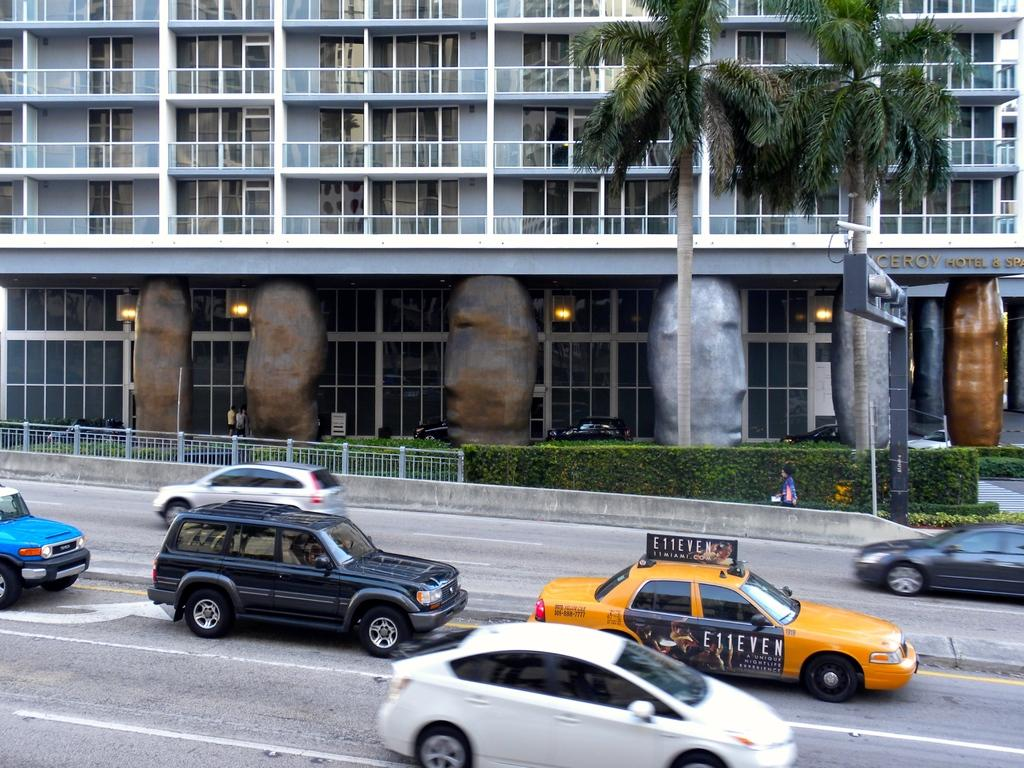<image>
Summarize the visual content of the image. a taxi with the number 11 on it 